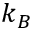Convert formula to latex. <formula><loc_0><loc_0><loc_500><loc_500>k _ { B }</formula> 